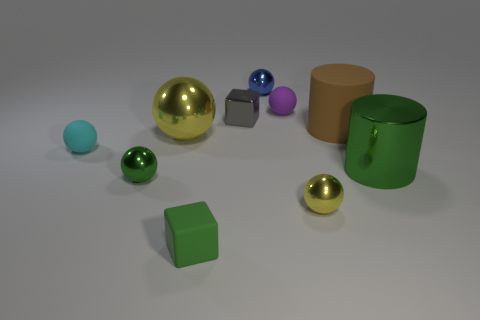Is the tiny matte block the same color as the metal cylinder?
Offer a terse response. Yes. What size is the thing that is behind the small green metal thing and in front of the cyan rubber object?
Make the answer very short. Large. What is the color of the cube that is made of the same material as the tiny green ball?
Your answer should be very brief. Gray. How many purple things have the same material as the big green cylinder?
Ensure brevity in your answer.  0. Are there the same number of yellow metallic things that are to the left of the tiny gray thing and small purple rubber objects right of the small cyan sphere?
Keep it short and to the point. Yes. Does the brown matte object have the same shape as the yellow metallic thing left of the small purple rubber object?
Provide a succinct answer. No. What material is the cube that is the same color as the metallic cylinder?
Keep it short and to the point. Rubber. Is the material of the small yellow ball the same as the tiny blue ball that is behind the green block?
Make the answer very short. Yes. There is a tiny shiny sphere that is on the left side of the yellow ball that is on the left side of the metallic sphere right of the purple sphere; what is its color?
Ensure brevity in your answer.  Green. Is the color of the metal cylinder the same as the rubber ball that is to the right of the small blue metallic object?
Make the answer very short. No. 